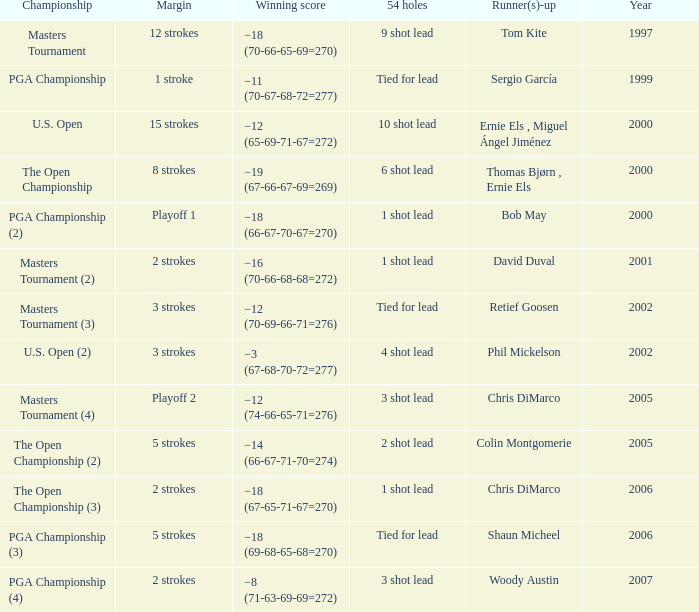 what's the margin where runner(s)-up is phil mickelson 3 strokes. 